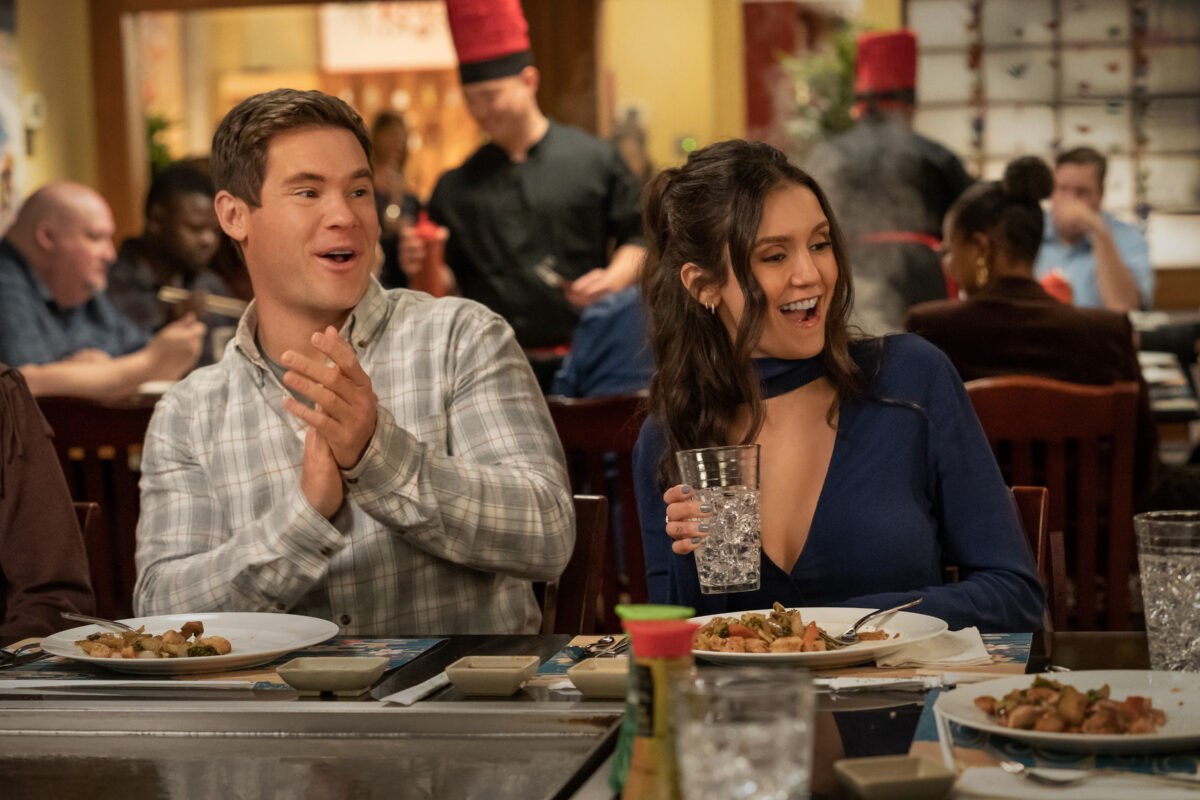What kind of meal are they having, and what does it signify about the setting? They seem to be enjoying a teppanyaki-style meal, characterized by an array of dishes like grilled meats and vegetables cooked on a large iron griddle. This style of dining is interactive and often celebratory, implying they are in a setting that values engagement and entertainment. Explain the cultural significance of teppanyaki in dining. Teppanyaki is a Japanese style of cooking that combines culinary art with performance, emphasizing the skill of the chef and the visual preparation of food. It promotes sharing and interaction among guests, enhancing communal bonds and offering a unique culinary experience that goes beyond just eating. 